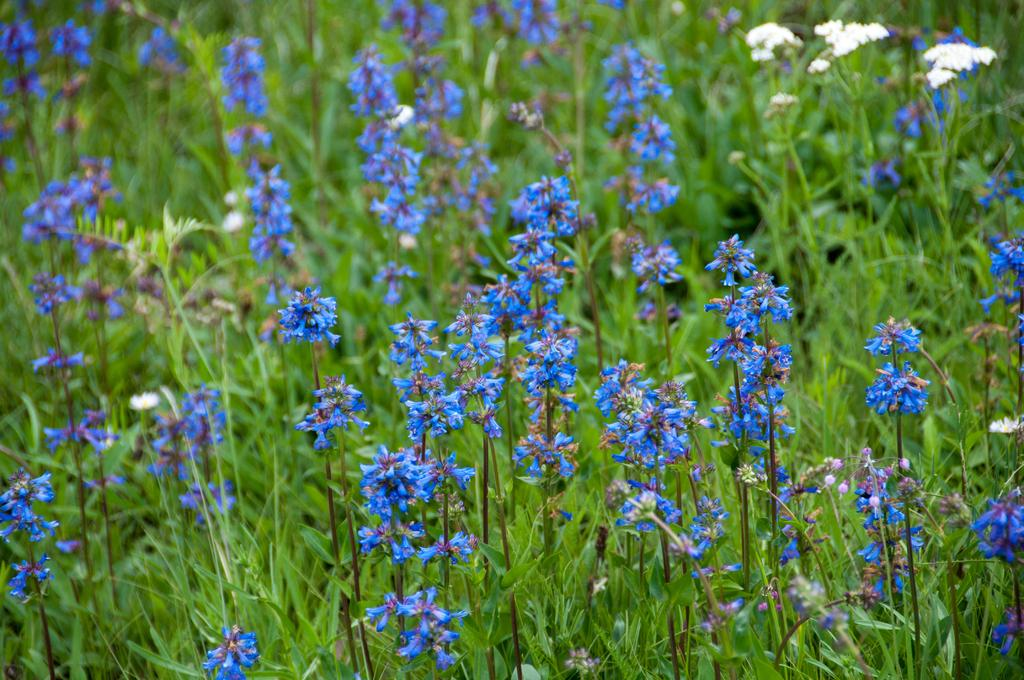What color are the flowers in the image? The flowers in the image are blue. What else can be seen in the background of the image? There are plants in the background of the image. What type of bead is used to decorate the birthday plate in the image? There is no birthday plate or beads present in the image; it only features blue color flowers and plants in the background. 